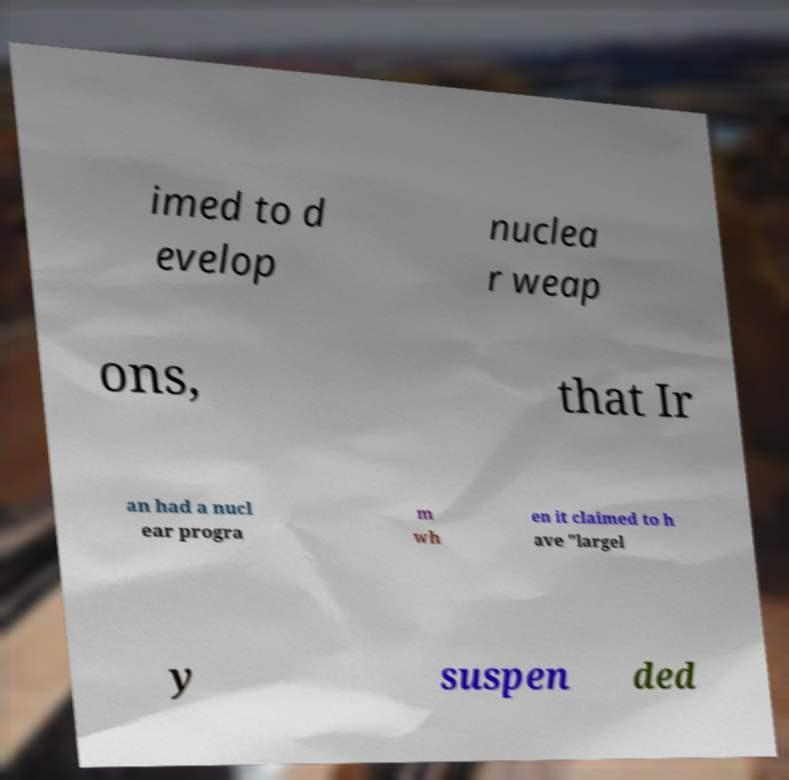Can you accurately transcribe the text from the provided image for me? imed to d evelop nuclea r weap ons, that Ir an had a nucl ear progra m wh en it claimed to h ave "largel y suspen ded 